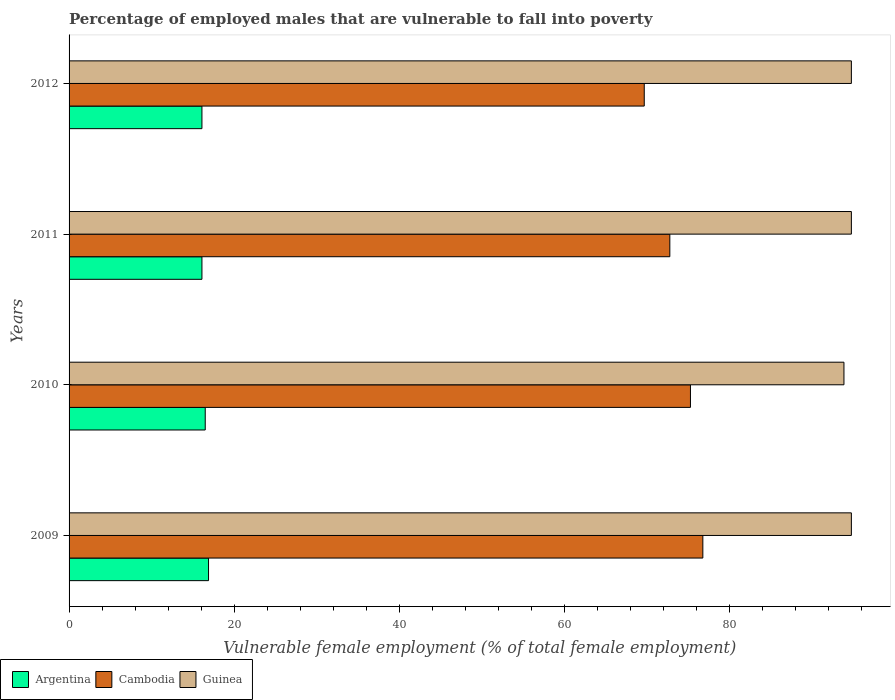How many different coloured bars are there?
Make the answer very short. 3. Are the number of bars per tick equal to the number of legend labels?
Your answer should be compact. Yes. What is the percentage of employed males who are vulnerable to fall into poverty in Guinea in 2012?
Offer a terse response. 94.8. Across all years, what is the maximum percentage of employed males who are vulnerable to fall into poverty in Cambodia?
Give a very brief answer. 76.8. Across all years, what is the minimum percentage of employed males who are vulnerable to fall into poverty in Argentina?
Offer a terse response. 16.1. In which year was the percentage of employed males who are vulnerable to fall into poverty in Argentina maximum?
Your answer should be very brief. 2009. What is the total percentage of employed males who are vulnerable to fall into poverty in Guinea in the graph?
Offer a terse response. 378.3. What is the difference between the percentage of employed males who are vulnerable to fall into poverty in Cambodia in 2009 and the percentage of employed males who are vulnerable to fall into poverty in Guinea in 2011?
Provide a short and direct response. -18. What is the average percentage of employed males who are vulnerable to fall into poverty in Cambodia per year?
Offer a very short reply. 73.65. In the year 2009, what is the difference between the percentage of employed males who are vulnerable to fall into poverty in Guinea and percentage of employed males who are vulnerable to fall into poverty in Argentina?
Provide a short and direct response. 77.9. What is the ratio of the percentage of employed males who are vulnerable to fall into poverty in Guinea in 2010 to that in 2011?
Give a very brief answer. 0.99. Is the percentage of employed males who are vulnerable to fall into poverty in Guinea in 2009 less than that in 2010?
Your answer should be compact. No. Is the difference between the percentage of employed males who are vulnerable to fall into poverty in Guinea in 2010 and 2011 greater than the difference between the percentage of employed males who are vulnerable to fall into poverty in Argentina in 2010 and 2011?
Give a very brief answer. No. What is the difference between the highest and the lowest percentage of employed males who are vulnerable to fall into poverty in Cambodia?
Ensure brevity in your answer.  7.1. Is the sum of the percentage of employed males who are vulnerable to fall into poverty in Guinea in 2011 and 2012 greater than the maximum percentage of employed males who are vulnerable to fall into poverty in Argentina across all years?
Your response must be concise. Yes. What does the 1st bar from the top in 2012 represents?
Ensure brevity in your answer.  Guinea. Is it the case that in every year, the sum of the percentage of employed males who are vulnerable to fall into poverty in Guinea and percentage of employed males who are vulnerable to fall into poverty in Argentina is greater than the percentage of employed males who are vulnerable to fall into poverty in Cambodia?
Make the answer very short. Yes. How many years are there in the graph?
Provide a succinct answer. 4. What is the title of the graph?
Keep it short and to the point. Percentage of employed males that are vulnerable to fall into poverty. Does "Malawi" appear as one of the legend labels in the graph?
Keep it short and to the point. No. What is the label or title of the X-axis?
Your response must be concise. Vulnerable female employment (% of total female employment). What is the label or title of the Y-axis?
Your response must be concise. Years. What is the Vulnerable female employment (% of total female employment) in Argentina in 2009?
Your answer should be very brief. 16.9. What is the Vulnerable female employment (% of total female employment) of Cambodia in 2009?
Give a very brief answer. 76.8. What is the Vulnerable female employment (% of total female employment) in Guinea in 2009?
Your answer should be very brief. 94.8. What is the Vulnerable female employment (% of total female employment) of Argentina in 2010?
Offer a terse response. 16.5. What is the Vulnerable female employment (% of total female employment) of Cambodia in 2010?
Your answer should be compact. 75.3. What is the Vulnerable female employment (% of total female employment) of Guinea in 2010?
Your response must be concise. 93.9. What is the Vulnerable female employment (% of total female employment) in Argentina in 2011?
Give a very brief answer. 16.1. What is the Vulnerable female employment (% of total female employment) in Cambodia in 2011?
Make the answer very short. 72.8. What is the Vulnerable female employment (% of total female employment) of Guinea in 2011?
Provide a succinct answer. 94.8. What is the Vulnerable female employment (% of total female employment) of Argentina in 2012?
Give a very brief answer. 16.1. What is the Vulnerable female employment (% of total female employment) in Cambodia in 2012?
Make the answer very short. 69.7. What is the Vulnerable female employment (% of total female employment) in Guinea in 2012?
Offer a terse response. 94.8. Across all years, what is the maximum Vulnerable female employment (% of total female employment) in Argentina?
Keep it short and to the point. 16.9. Across all years, what is the maximum Vulnerable female employment (% of total female employment) in Cambodia?
Give a very brief answer. 76.8. Across all years, what is the maximum Vulnerable female employment (% of total female employment) in Guinea?
Your answer should be compact. 94.8. Across all years, what is the minimum Vulnerable female employment (% of total female employment) of Argentina?
Keep it short and to the point. 16.1. Across all years, what is the minimum Vulnerable female employment (% of total female employment) of Cambodia?
Offer a very short reply. 69.7. Across all years, what is the minimum Vulnerable female employment (% of total female employment) of Guinea?
Your response must be concise. 93.9. What is the total Vulnerable female employment (% of total female employment) in Argentina in the graph?
Your response must be concise. 65.6. What is the total Vulnerable female employment (% of total female employment) in Cambodia in the graph?
Your answer should be compact. 294.6. What is the total Vulnerable female employment (% of total female employment) in Guinea in the graph?
Ensure brevity in your answer.  378.3. What is the difference between the Vulnerable female employment (% of total female employment) of Guinea in 2009 and that in 2010?
Make the answer very short. 0.9. What is the difference between the Vulnerable female employment (% of total female employment) of Argentina in 2010 and that in 2011?
Keep it short and to the point. 0.4. What is the difference between the Vulnerable female employment (% of total female employment) of Cambodia in 2010 and that in 2011?
Make the answer very short. 2.5. What is the difference between the Vulnerable female employment (% of total female employment) of Cambodia in 2010 and that in 2012?
Ensure brevity in your answer.  5.6. What is the difference between the Vulnerable female employment (% of total female employment) of Guinea in 2010 and that in 2012?
Make the answer very short. -0.9. What is the difference between the Vulnerable female employment (% of total female employment) of Argentina in 2011 and that in 2012?
Offer a terse response. 0. What is the difference between the Vulnerable female employment (% of total female employment) in Argentina in 2009 and the Vulnerable female employment (% of total female employment) in Cambodia in 2010?
Ensure brevity in your answer.  -58.4. What is the difference between the Vulnerable female employment (% of total female employment) in Argentina in 2009 and the Vulnerable female employment (% of total female employment) in Guinea in 2010?
Make the answer very short. -77. What is the difference between the Vulnerable female employment (% of total female employment) in Cambodia in 2009 and the Vulnerable female employment (% of total female employment) in Guinea in 2010?
Make the answer very short. -17.1. What is the difference between the Vulnerable female employment (% of total female employment) in Argentina in 2009 and the Vulnerable female employment (% of total female employment) in Cambodia in 2011?
Give a very brief answer. -55.9. What is the difference between the Vulnerable female employment (% of total female employment) in Argentina in 2009 and the Vulnerable female employment (% of total female employment) in Guinea in 2011?
Offer a very short reply. -77.9. What is the difference between the Vulnerable female employment (% of total female employment) in Argentina in 2009 and the Vulnerable female employment (% of total female employment) in Cambodia in 2012?
Provide a short and direct response. -52.8. What is the difference between the Vulnerable female employment (% of total female employment) of Argentina in 2009 and the Vulnerable female employment (% of total female employment) of Guinea in 2012?
Offer a very short reply. -77.9. What is the difference between the Vulnerable female employment (% of total female employment) of Cambodia in 2009 and the Vulnerable female employment (% of total female employment) of Guinea in 2012?
Your answer should be compact. -18. What is the difference between the Vulnerable female employment (% of total female employment) of Argentina in 2010 and the Vulnerable female employment (% of total female employment) of Cambodia in 2011?
Offer a terse response. -56.3. What is the difference between the Vulnerable female employment (% of total female employment) of Argentina in 2010 and the Vulnerable female employment (% of total female employment) of Guinea in 2011?
Offer a very short reply. -78.3. What is the difference between the Vulnerable female employment (% of total female employment) in Cambodia in 2010 and the Vulnerable female employment (% of total female employment) in Guinea in 2011?
Provide a succinct answer. -19.5. What is the difference between the Vulnerable female employment (% of total female employment) in Argentina in 2010 and the Vulnerable female employment (% of total female employment) in Cambodia in 2012?
Keep it short and to the point. -53.2. What is the difference between the Vulnerable female employment (% of total female employment) of Argentina in 2010 and the Vulnerable female employment (% of total female employment) of Guinea in 2012?
Offer a terse response. -78.3. What is the difference between the Vulnerable female employment (% of total female employment) of Cambodia in 2010 and the Vulnerable female employment (% of total female employment) of Guinea in 2012?
Keep it short and to the point. -19.5. What is the difference between the Vulnerable female employment (% of total female employment) of Argentina in 2011 and the Vulnerable female employment (% of total female employment) of Cambodia in 2012?
Your response must be concise. -53.6. What is the difference between the Vulnerable female employment (% of total female employment) in Argentina in 2011 and the Vulnerable female employment (% of total female employment) in Guinea in 2012?
Offer a terse response. -78.7. What is the average Vulnerable female employment (% of total female employment) in Argentina per year?
Provide a succinct answer. 16.4. What is the average Vulnerable female employment (% of total female employment) of Cambodia per year?
Make the answer very short. 73.65. What is the average Vulnerable female employment (% of total female employment) in Guinea per year?
Provide a short and direct response. 94.58. In the year 2009, what is the difference between the Vulnerable female employment (% of total female employment) in Argentina and Vulnerable female employment (% of total female employment) in Cambodia?
Your answer should be compact. -59.9. In the year 2009, what is the difference between the Vulnerable female employment (% of total female employment) of Argentina and Vulnerable female employment (% of total female employment) of Guinea?
Offer a very short reply. -77.9. In the year 2009, what is the difference between the Vulnerable female employment (% of total female employment) of Cambodia and Vulnerable female employment (% of total female employment) of Guinea?
Keep it short and to the point. -18. In the year 2010, what is the difference between the Vulnerable female employment (% of total female employment) of Argentina and Vulnerable female employment (% of total female employment) of Cambodia?
Offer a terse response. -58.8. In the year 2010, what is the difference between the Vulnerable female employment (% of total female employment) in Argentina and Vulnerable female employment (% of total female employment) in Guinea?
Your response must be concise. -77.4. In the year 2010, what is the difference between the Vulnerable female employment (% of total female employment) in Cambodia and Vulnerable female employment (% of total female employment) in Guinea?
Your answer should be compact. -18.6. In the year 2011, what is the difference between the Vulnerable female employment (% of total female employment) in Argentina and Vulnerable female employment (% of total female employment) in Cambodia?
Your answer should be very brief. -56.7. In the year 2011, what is the difference between the Vulnerable female employment (% of total female employment) in Argentina and Vulnerable female employment (% of total female employment) in Guinea?
Your answer should be compact. -78.7. In the year 2012, what is the difference between the Vulnerable female employment (% of total female employment) of Argentina and Vulnerable female employment (% of total female employment) of Cambodia?
Provide a succinct answer. -53.6. In the year 2012, what is the difference between the Vulnerable female employment (% of total female employment) of Argentina and Vulnerable female employment (% of total female employment) of Guinea?
Your answer should be compact. -78.7. In the year 2012, what is the difference between the Vulnerable female employment (% of total female employment) of Cambodia and Vulnerable female employment (% of total female employment) of Guinea?
Provide a succinct answer. -25.1. What is the ratio of the Vulnerable female employment (% of total female employment) in Argentina in 2009 to that in 2010?
Give a very brief answer. 1.02. What is the ratio of the Vulnerable female employment (% of total female employment) in Cambodia in 2009 to that in 2010?
Offer a very short reply. 1.02. What is the ratio of the Vulnerable female employment (% of total female employment) in Guinea in 2009 to that in 2010?
Make the answer very short. 1.01. What is the ratio of the Vulnerable female employment (% of total female employment) in Argentina in 2009 to that in 2011?
Ensure brevity in your answer.  1.05. What is the ratio of the Vulnerable female employment (% of total female employment) of Cambodia in 2009 to that in 2011?
Your response must be concise. 1.05. What is the ratio of the Vulnerable female employment (% of total female employment) in Guinea in 2009 to that in 2011?
Your answer should be compact. 1. What is the ratio of the Vulnerable female employment (% of total female employment) of Argentina in 2009 to that in 2012?
Keep it short and to the point. 1.05. What is the ratio of the Vulnerable female employment (% of total female employment) of Cambodia in 2009 to that in 2012?
Make the answer very short. 1.1. What is the ratio of the Vulnerable female employment (% of total female employment) of Guinea in 2009 to that in 2012?
Your answer should be very brief. 1. What is the ratio of the Vulnerable female employment (% of total female employment) of Argentina in 2010 to that in 2011?
Make the answer very short. 1.02. What is the ratio of the Vulnerable female employment (% of total female employment) of Cambodia in 2010 to that in 2011?
Your response must be concise. 1.03. What is the ratio of the Vulnerable female employment (% of total female employment) in Argentina in 2010 to that in 2012?
Your answer should be compact. 1.02. What is the ratio of the Vulnerable female employment (% of total female employment) in Cambodia in 2010 to that in 2012?
Your response must be concise. 1.08. What is the ratio of the Vulnerable female employment (% of total female employment) in Guinea in 2010 to that in 2012?
Keep it short and to the point. 0.99. What is the ratio of the Vulnerable female employment (% of total female employment) of Cambodia in 2011 to that in 2012?
Provide a short and direct response. 1.04. What is the difference between the highest and the lowest Vulnerable female employment (% of total female employment) of Argentina?
Offer a terse response. 0.8. 